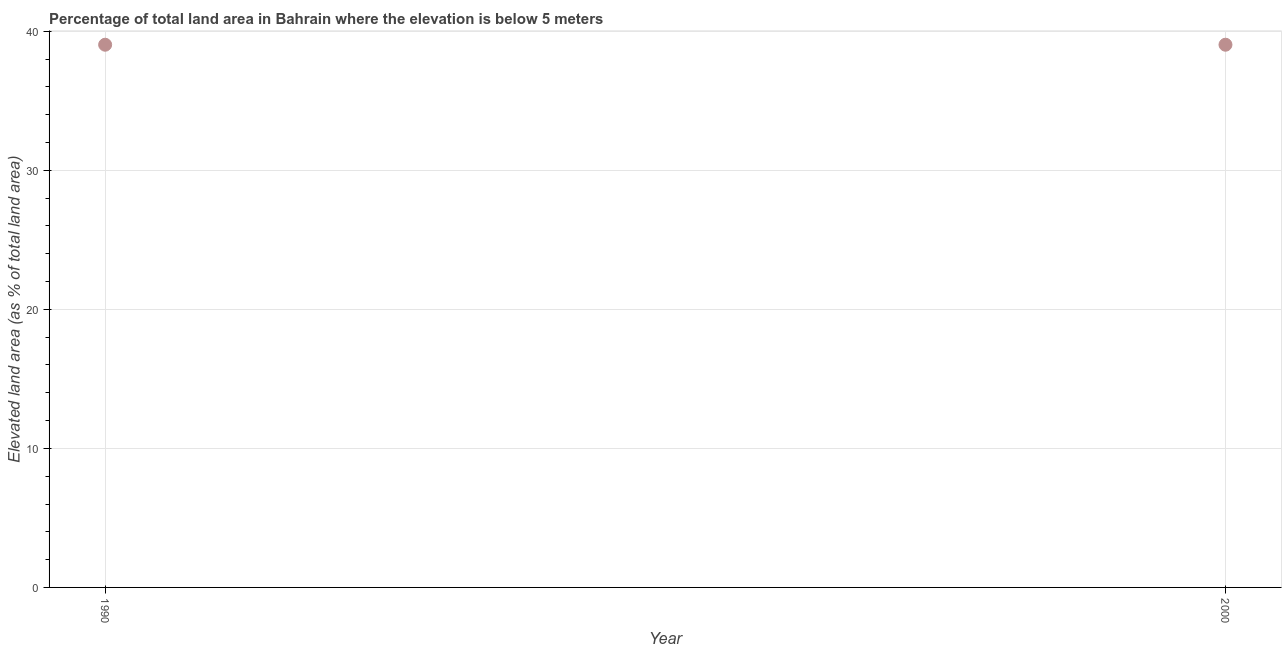What is the total elevated land area in 2000?
Offer a very short reply. 39.03. Across all years, what is the maximum total elevated land area?
Offer a terse response. 39.03. Across all years, what is the minimum total elevated land area?
Offer a terse response. 39.03. What is the sum of the total elevated land area?
Keep it short and to the point. 78.07. What is the difference between the total elevated land area in 1990 and 2000?
Offer a terse response. 0. What is the average total elevated land area per year?
Keep it short and to the point. 39.03. What is the median total elevated land area?
Make the answer very short. 39.03. In how many years, is the total elevated land area greater than 6 %?
Make the answer very short. 2. Is the total elevated land area in 1990 less than that in 2000?
Provide a succinct answer. No. In how many years, is the total elevated land area greater than the average total elevated land area taken over all years?
Ensure brevity in your answer.  0. Does the graph contain any zero values?
Provide a short and direct response. No. Does the graph contain grids?
Provide a succinct answer. Yes. What is the title of the graph?
Offer a very short reply. Percentage of total land area in Bahrain where the elevation is below 5 meters. What is the label or title of the Y-axis?
Keep it short and to the point. Elevated land area (as % of total land area). What is the Elevated land area (as % of total land area) in 1990?
Ensure brevity in your answer.  39.03. What is the Elevated land area (as % of total land area) in 2000?
Offer a terse response. 39.03. What is the ratio of the Elevated land area (as % of total land area) in 1990 to that in 2000?
Provide a succinct answer. 1. 